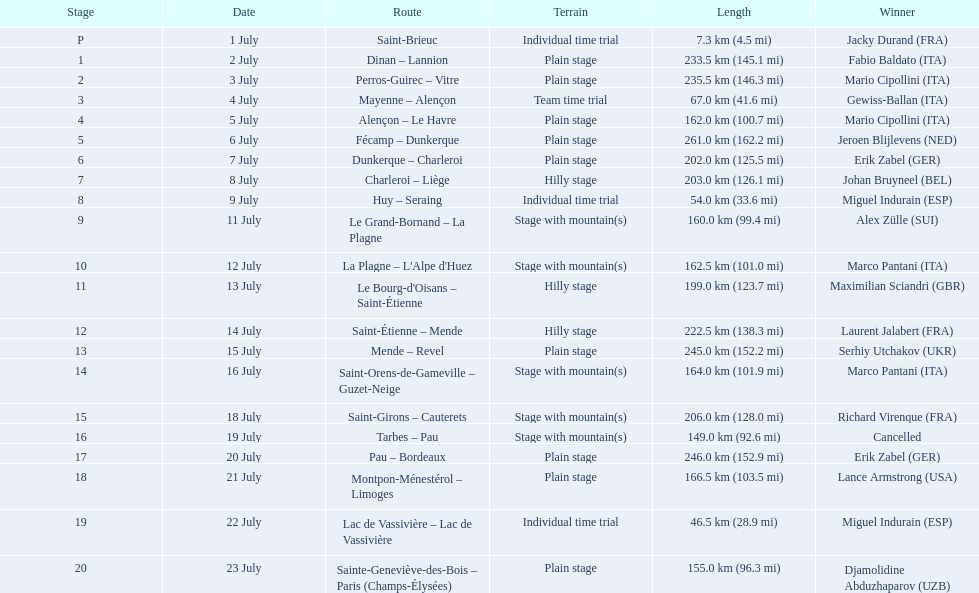What are the specific dates? 1 July, 2 July, 3 July, 4 July, 5 July, 6 July, 7 July, 8 July, 9 July, 11 July, 12 July, 13 July, 14 July, 15 July, 16 July, 18 July, 19 July, 20 July, 21 July, 22 July, 23 July. How long is it on july 8th? 203.0 km (126.1 mi). Parse the table in full. {'header': ['Stage', 'Date', 'Route', 'Terrain', 'Length', 'Winner'], 'rows': [['P', '1 July', 'Saint-Brieuc', 'Individual time trial', '7.3\xa0km (4.5\xa0mi)', 'Jacky Durand\xa0(FRA)'], ['1', '2 July', 'Dinan – Lannion', 'Plain stage', '233.5\xa0km (145.1\xa0mi)', 'Fabio Baldato\xa0(ITA)'], ['2', '3 July', 'Perros-Guirec – Vitre', 'Plain stage', '235.5\xa0km (146.3\xa0mi)', 'Mario Cipollini\xa0(ITA)'], ['3', '4 July', 'Mayenne – Alençon', 'Team time trial', '67.0\xa0km (41.6\xa0mi)', 'Gewiss-Ballan\xa0(ITA)'], ['4', '5 July', 'Alençon – Le Havre', 'Plain stage', '162.0\xa0km (100.7\xa0mi)', 'Mario Cipollini\xa0(ITA)'], ['5', '6 July', 'Fécamp – Dunkerque', 'Plain stage', '261.0\xa0km (162.2\xa0mi)', 'Jeroen Blijlevens\xa0(NED)'], ['6', '7 July', 'Dunkerque – Charleroi', 'Plain stage', '202.0\xa0km (125.5\xa0mi)', 'Erik Zabel\xa0(GER)'], ['7', '8 July', 'Charleroi – Liège', 'Hilly stage', '203.0\xa0km (126.1\xa0mi)', 'Johan Bruyneel\xa0(BEL)'], ['8', '9 July', 'Huy – Seraing', 'Individual time trial', '54.0\xa0km (33.6\xa0mi)', 'Miguel Indurain\xa0(ESP)'], ['9', '11 July', 'Le Grand-Bornand – La Plagne', 'Stage with mountain(s)', '160.0\xa0km (99.4\xa0mi)', 'Alex Zülle\xa0(SUI)'], ['10', '12 July', "La Plagne – L'Alpe d'Huez", 'Stage with mountain(s)', '162.5\xa0km (101.0\xa0mi)', 'Marco Pantani\xa0(ITA)'], ['11', '13 July', "Le Bourg-d'Oisans – Saint-Étienne", 'Hilly stage', '199.0\xa0km (123.7\xa0mi)', 'Maximilian Sciandri\xa0(GBR)'], ['12', '14 July', 'Saint-Étienne – Mende', 'Hilly stage', '222.5\xa0km (138.3\xa0mi)', 'Laurent Jalabert\xa0(FRA)'], ['13', '15 July', 'Mende – Revel', 'Plain stage', '245.0\xa0km (152.2\xa0mi)', 'Serhiy Utchakov\xa0(UKR)'], ['14', '16 July', 'Saint-Orens-de-Gameville – Guzet-Neige', 'Stage with mountain(s)', '164.0\xa0km (101.9\xa0mi)', 'Marco Pantani\xa0(ITA)'], ['15', '18 July', 'Saint-Girons – Cauterets', 'Stage with mountain(s)', '206.0\xa0km (128.0\xa0mi)', 'Richard Virenque\xa0(FRA)'], ['16', '19 July', 'Tarbes – Pau', 'Stage with mountain(s)', '149.0\xa0km (92.6\xa0mi)', 'Cancelled'], ['17', '20 July', 'Pau – Bordeaux', 'Plain stage', '246.0\xa0km (152.9\xa0mi)', 'Erik Zabel\xa0(GER)'], ['18', '21 July', 'Montpon-Ménestérol – Limoges', 'Plain stage', '166.5\xa0km (103.5\xa0mi)', 'Lance Armstrong\xa0(USA)'], ['19', '22 July', 'Lac de Vassivière – Lac de Vassivière', 'Individual time trial', '46.5\xa0km (28.9\xa0mi)', 'Miguel Indurain\xa0(ESP)'], ['20', '23 July', 'Sainte-Geneviève-des-Bois – Paris (Champs-Élysées)', 'Plain stage', '155.0\xa0km (96.3\xa0mi)', 'Djamolidine Abduzhaparov\xa0(UZB)']]} 